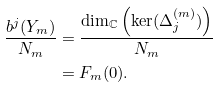Convert formula to latex. <formula><loc_0><loc_0><loc_500><loc_500>\frac { b ^ { j } ( Y _ { m } ) } { N _ { m } } & = \frac { \dim _ { \mathbb { C } } \left ( \ker ( \Delta _ { j } ^ { ( m ) } ) \right ) } { N _ { m } } \\ & = F _ { m } ( 0 ) .</formula> 